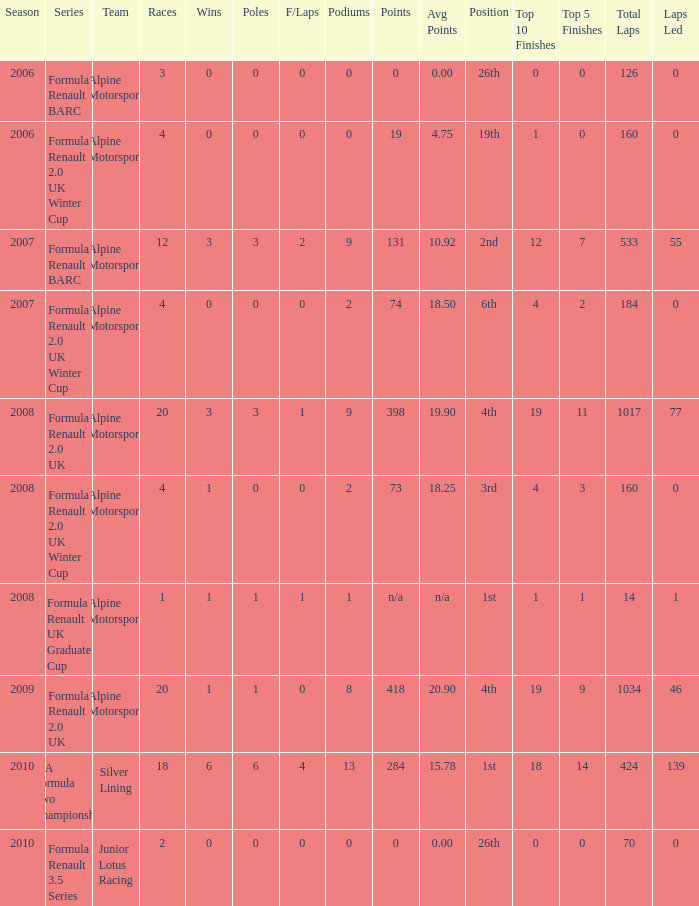What races achieved 0 f/laps and 1 pole position? 20.0. 